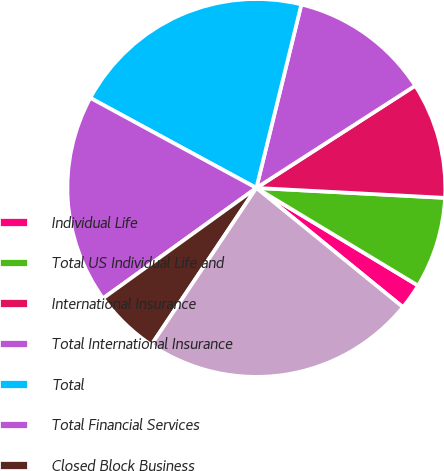Convert chart. <chart><loc_0><loc_0><loc_500><loc_500><pie_chart><fcel>Individual Life<fcel>Total US Individual Life and<fcel>International Insurance<fcel>Total International Insurance<fcel>Total<fcel>Total Financial Services<fcel>Closed Block Business<fcel>Total per Consolidated<nl><fcel>2.22%<fcel>7.81%<fcel>9.94%<fcel>12.07%<fcel>20.92%<fcel>17.84%<fcel>5.68%<fcel>23.52%<nl></chart> 